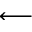<formula> <loc_0><loc_0><loc_500><loc_500>\longleftarrow</formula> 